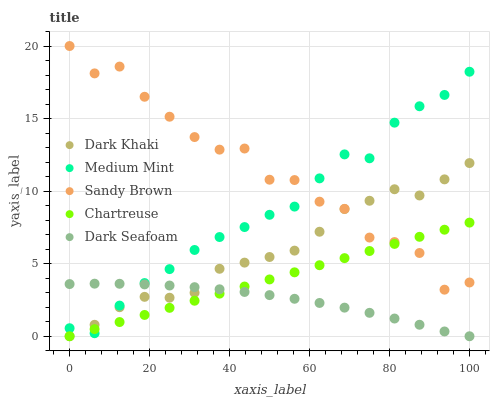Does Dark Seafoam have the minimum area under the curve?
Answer yes or no. Yes. Does Sandy Brown have the maximum area under the curve?
Answer yes or no. Yes. Does Medium Mint have the minimum area under the curve?
Answer yes or no. No. Does Medium Mint have the maximum area under the curve?
Answer yes or no. No. Is Chartreuse the smoothest?
Answer yes or no. Yes. Is Sandy Brown the roughest?
Answer yes or no. Yes. Is Medium Mint the smoothest?
Answer yes or no. No. Is Medium Mint the roughest?
Answer yes or no. No. Does Dark Khaki have the lowest value?
Answer yes or no. Yes. Does Medium Mint have the lowest value?
Answer yes or no. No. Does Sandy Brown have the highest value?
Answer yes or no. Yes. Does Medium Mint have the highest value?
Answer yes or no. No. Is Dark Seafoam less than Sandy Brown?
Answer yes or no. Yes. Is Sandy Brown greater than Dark Seafoam?
Answer yes or no. Yes. Does Sandy Brown intersect Chartreuse?
Answer yes or no. Yes. Is Sandy Brown less than Chartreuse?
Answer yes or no. No. Is Sandy Brown greater than Chartreuse?
Answer yes or no. No. Does Dark Seafoam intersect Sandy Brown?
Answer yes or no. No. 